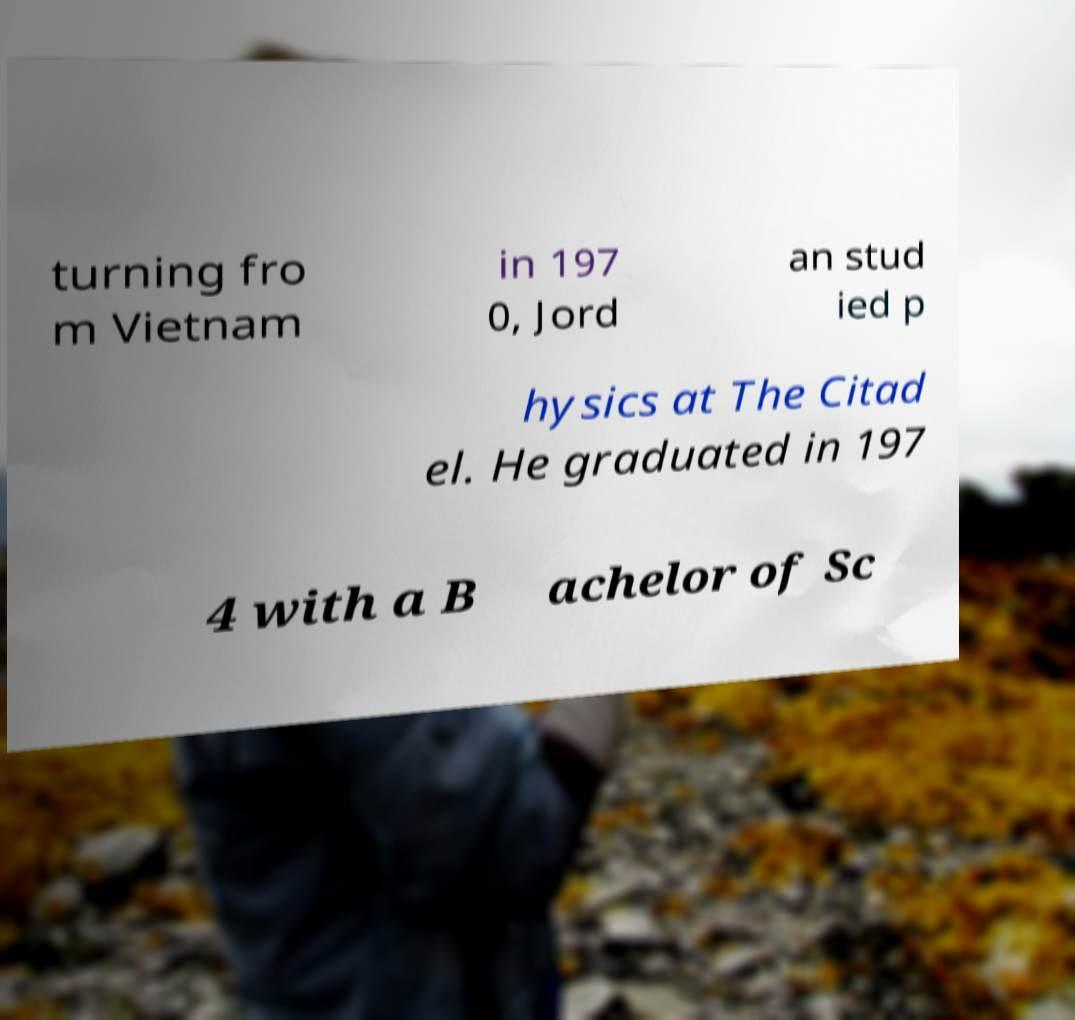Can you read and provide the text displayed in the image?This photo seems to have some interesting text. Can you extract and type it out for me? turning fro m Vietnam in 197 0, Jord an stud ied p hysics at The Citad el. He graduated in 197 4 with a B achelor of Sc 